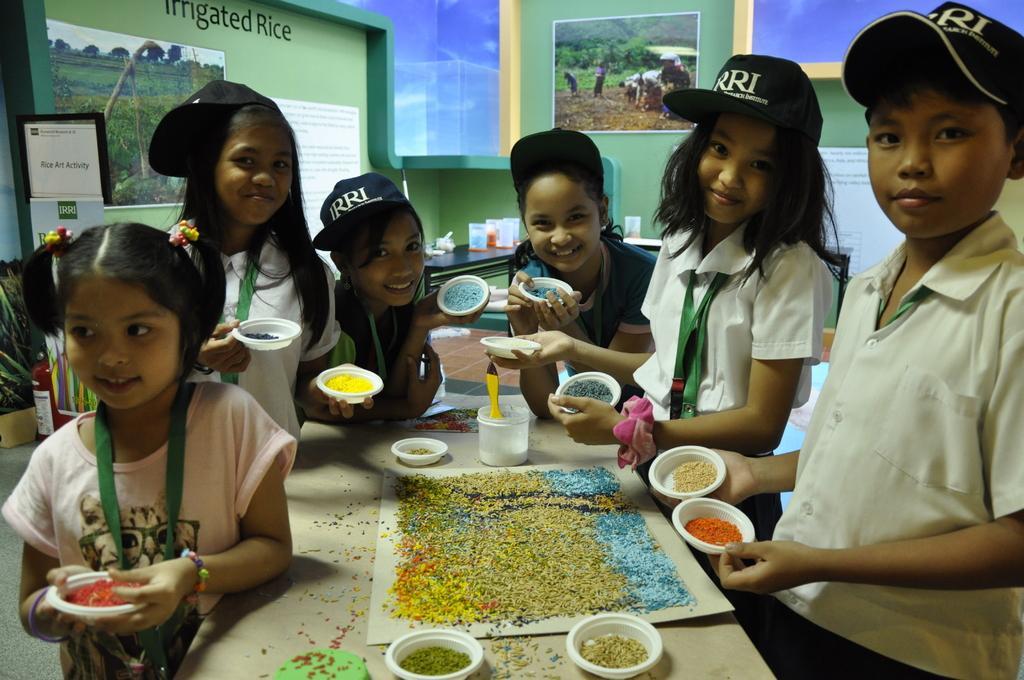Can you describe this image briefly? In this image I can see number of children are standing and I can also see all of them are holding white colour plates. I can also see except one rest all are wearing caps. In the centre I can see a table and on it I can see few more plates, aboard, a plastic container and in it I can see a yellow colour thing. I can also see number of colourful things on the plates and on the table. In the background I can see number of posters, few more containers and on the top left side of this image I can see something is written on the wall. On the left side I can see a plant and a fire extinguisher. 